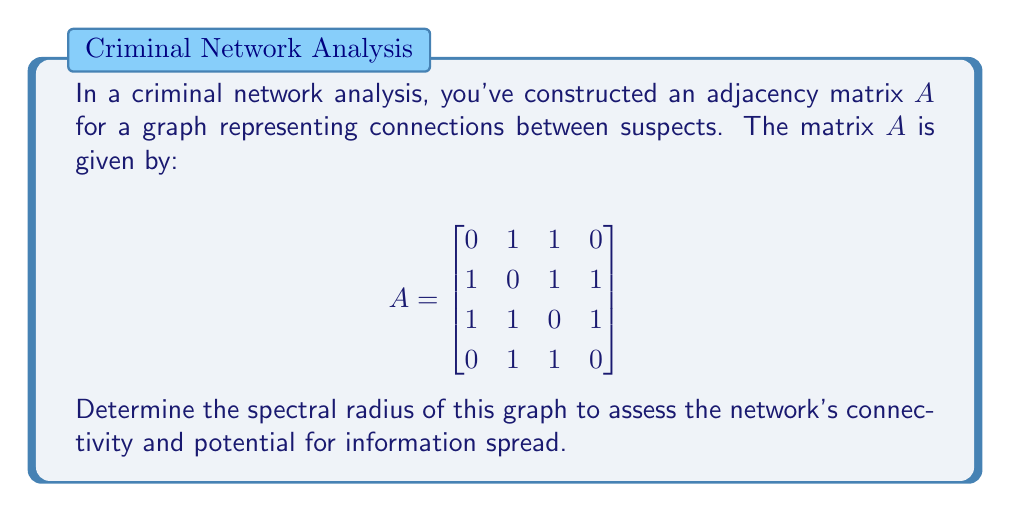Give your solution to this math problem. To find the spectral radius of the graph, we need to follow these steps:

1) The spectral radius is the largest absolute eigenvalue of the adjacency matrix $A$.

2) To find the eigenvalues, we need to solve the characteristic equation:
   $\det(A - \lambda I) = 0$

3) Expanding the determinant:
   $$\begin{vmatrix}
   -\lambda & 1 & 1 & 0 \\
   1 & -\lambda & 1 & 1 \\
   1 & 1 & -\lambda & 1 \\
   0 & 1 & 1 & -\lambda
   \end{vmatrix} = 0$$

4) This expands to the polynomial:
   $\lambda^4 - 5\lambda^2 - 4\lambda + 1 = 0$

5) This is a 4th degree polynomial, which is difficult to solve by hand. However, we can use the fact that for this type of graph (simple, undirected), the largest eigenvalue is always real and positive.

6) Using numerical methods or a computer algebra system, we can find that the roots of this polynomial are approximately:
   $\lambda_1 \approx 2.4812$
   $\lambda_2 \approx 0.5616$
   $\lambda_3 \approx -1.5616$
   $\lambda_4 \approx -1.4812$

7) The spectral radius is the largest absolute value among these, which is $\lambda_1 \approx 2.4812$.

This value indicates a moderately connected network, suggesting potential for information spread but not as extensive as in a fully connected graph.
Answer: $2.4812$ 